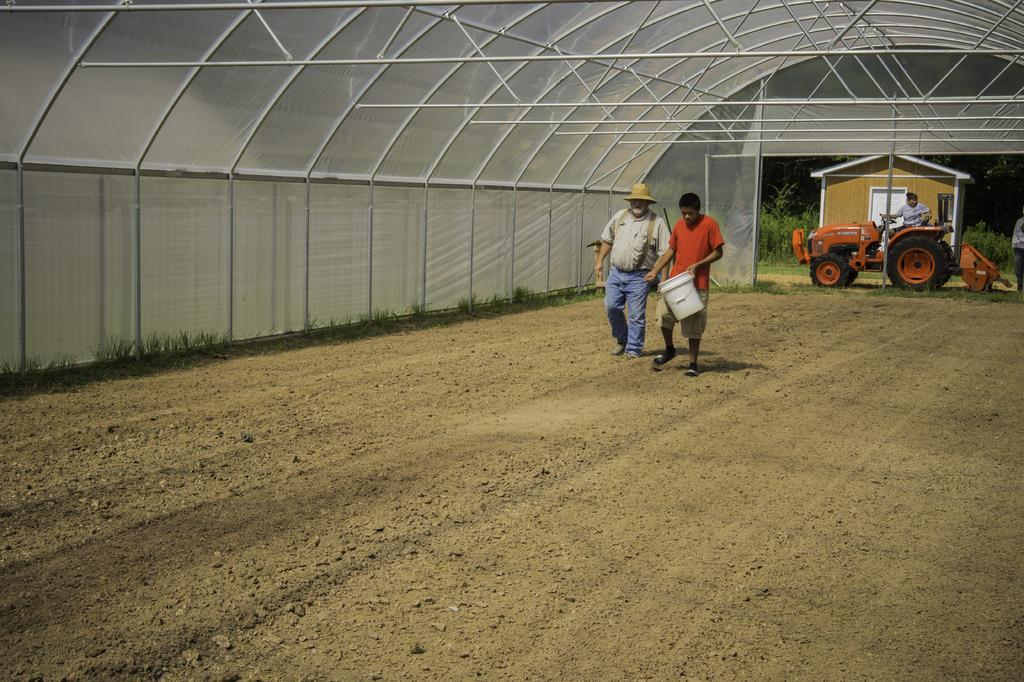Please provide a concise description of this image. In this image I can see a person wearing orange t shirt is standing and holding a while colored bucket and another person wearing white and blue colored dress is standing. In the background I can see a orange colored vehicle, a person sitting on it, a house, few trees and the shed. 